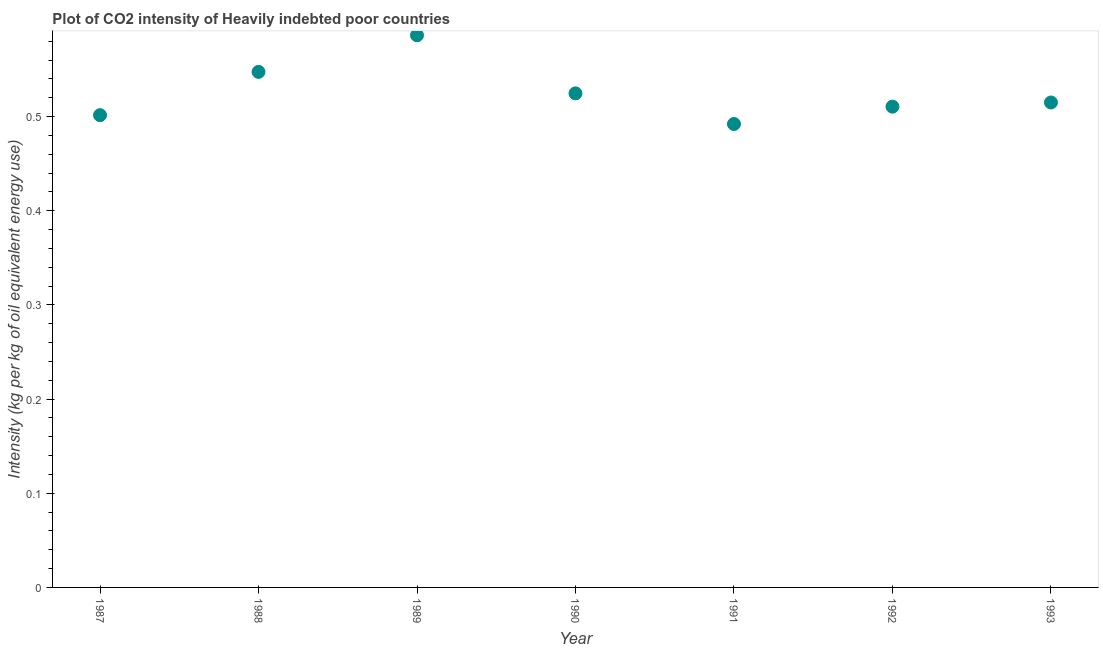What is the co2 intensity in 1993?
Offer a terse response. 0.51. Across all years, what is the maximum co2 intensity?
Your answer should be very brief. 0.59. Across all years, what is the minimum co2 intensity?
Offer a terse response. 0.49. In which year was the co2 intensity maximum?
Your answer should be compact. 1989. In which year was the co2 intensity minimum?
Keep it short and to the point. 1991. What is the sum of the co2 intensity?
Your response must be concise. 3.68. What is the difference between the co2 intensity in 1988 and 1993?
Keep it short and to the point. 0.03. What is the average co2 intensity per year?
Make the answer very short. 0.53. What is the median co2 intensity?
Your answer should be very brief. 0.51. Do a majority of the years between 1992 and 1991 (inclusive) have co2 intensity greater than 0.12000000000000001 kg?
Ensure brevity in your answer.  No. What is the ratio of the co2 intensity in 1990 to that in 1993?
Ensure brevity in your answer.  1.02. Is the difference between the co2 intensity in 1987 and 1992 greater than the difference between any two years?
Your response must be concise. No. What is the difference between the highest and the second highest co2 intensity?
Ensure brevity in your answer.  0.04. Is the sum of the co2 intensity in 1988 and 1990 greater than the maximum co2 intensity across all years?
Give a very brief answer. Yes. What is the difference between the highest and the lowest co2 intensity?
Your response must be concise. 0.09. Does the co2 intensity monotonically increase over the years?
Offer a very short reply. No. How many dotlines are there?
Ensure brevity in your answer.  1. How many years are there in the graph?
Your response must be concise. 7. What is the difference between two consecutive major ticks on the Y-axis?
Your answer should be very brief. 0.1. Are the values on the major ticks of Y-axis written in scientific E-notation?
Your response must be concise. No. Does the graph contain grids?
Your answer should be very brief. No. What is the title of the graph?
Make the answer very short. Plot of CO2 intensity of Heavily indebted poor countries. What is the label or title of the Y-axis?
Keep it short and to the point. Intensity (kg per kg of oil equivalent energy use). What is the Intensity (kg per kg of oil equivalent energy use) in 1987?
Make the answer very short. 0.5. What is the Intensity (kg per kg of oil equivalent energy use) in 1988?
Keep it short and to the point. 0.55. What is the Intensity (kg per kg of oil equivalent energy use) in 1989?
Keep it short and to the point. 0.59. What is the Intensity (kg per kg of oil equivalent energy use) in 1990?
Your answer should be compact. 0.52. What is the Intensity (kg per kg of oil equivalent energy use) in 1991?
Your answer should be very brief. 0.49. What is the Intensity (kg per kg of oil equivalent energy use) in 1992?
Your answer should be compact. 0.51. What is the Intensity (kg per kg of oil equivalent energy use) in 1993?
Make the answer very short. 0.51. What is the difference between the Intensity (kg per kg of oil equivalent energy use) in 1987 and 1988?
Your answer should be compact. -0.05. What is the difference between the Intensity (kg per kg of oil equivalent energy use) in 1987 and 1989?
Ensure brevity in your answer.  -0.08. What is the difference between the Intensity (kg per kg of oil equivalent energy use) in 1987 and 1990?
Your answer should be very brief. -0.02. What is the difference between the Intensity (kg per kg of oil equivalent energy use) in 1987 and 1991?
Provide a short and direct response. 0.01. What is the difference between the Intensity (kg per kg of oil equivalent energy use) in 1987 and 1992?
Ensure brevity in your answer.  -0.01. What is the difference between the Intensity (kg per kg of oil equivalent energy use) in 1987 and 1993?
Your answer should be compact. -0.01. What is the difference between the Intensity (kg per kg of oil equivalent energy use) in 1988 and 1989?
Provide a short and direct response. -0.04. What is the difference between the Intensity (kg per kg of oil equivalent energy use) in 1988 and 1990?
Make the answer very short. 0.02. What is the difference between the Intensity (kg per kg of oil equivalent energy use) in 1988 and 1991?
Offer a terse response. 0.06. What is the difference between the Intensity (kg per kg of oil equivalent energy use) in 1988 and 1992?
Make the answer very short. 0.04. What is the difference between the Intensity (kg per kg of oil equivalent energy use) in 1988 and 1993?
Your answer should be very brief. 0.03. What is the difference between the Intensity (kg per kg of oil equivalent energy use) in 1989 and 1990?
Your response must be concise. 0.06. What is the difference between the Intensity (kg per kg of oil equivalent energy use) in 1989 and 1991?
Offer a terse response. 0.09. What is the difference between the Intensity (kg per kg of oil equivalent energy use) in 1989 and 1992?
Offer a terse response. 0.08. What is the difference between the Intensity (kg per kg of oil equivalent energy use) in 1989 and 1993?
Your response must be concise. 0.07. What is the difference between the Intensity (kg per kg of oil equivalent energy use) in 1990 and 1991?
Your answer should be very brief. 0.03. What is the difference between the Intensity (kg per kg of oil equivalent energy use) in 1990 and 1992?
Provide a short and direct response. 0.01. What is the difference between the Intensity (kg per kg of oil equivalent energy use) in 1990 and 1993?
Keep it short and to the point. 0.01. What is the difference between the Intensity (kg per kg of oil equivalent energy use) in 1991 and 1992?
Your answer should be compact. -0.02. What is the difference between the Intensity (kg per kg of oil equivalent energy use) in 1991 and 1993?
Your answer should be compact. -0.02. What is the difference between the Intensity (kg per kg of oil equivalent energy use) in 1992 and 1993?
Ensure brevity in your answer.  -0. What is the ratio of the Intensity (kg per kg of oil equivalent energy use) in 1987 to that in 1988?
Give a very brief answer. 0.92. What is the ratio of the Intensity (kg per kg of oil equivalent energy use) in 1987 to that in 1989?
Give a very brief answer. 0.85. What is the ratio of the Intensity (kg per kg of oil equivalent energy use) in 1987 to that in 1990?
Your answer should be very brief. 0.96. What is the ratio of the Intensity (kg per kg of oil equivalent energy use) in 1987 to that in 1991?
Offer a terse response. 1.02. What is the ratio of the Intensity (kg per kg of oil equivalent energy use) in 1987 to that in 1992?
Keep it short and to the point. 0.98. What is the ratio of the Intensity (kg per kg of oil equivalent energy use) in 1988 to that in 1989?
Provide a succinct answer. 0.93. What is the ratio of the Intensity (kg per kg of oil equivalent energy use) in 1988 to that in 1990?
Keep it short and to the point. 1.04. What is the ratio of the Intensity (kg per kg of oil equivalent energy use) in 1988 to that in 1991?
Your answer should be compact. 1.11. What is the ratio of the Intensity (kg per kg of oil equivalent energy use) in 1988 to that in 1992?
Ensure brevity in your answer.  1.07. What is the ratio of the Intensity (kg per kg of oil equivalent energy use) in 1988 to that in 1993?
Provide a succinct answer. 1.06. What is the ratio of the Intensity (kg per kg of oil equivalent energy use) in 1989 to that in 1990?
Provide a succinct answer. 1.12. What is the ratio of the Intensity (kg per kg of oil equivalent energy use) in 1989 to that in 1991?
Give a very brief answer. 1.19. What is the ratio of the Intensity (kg per kg of oil equivalent energy use) in 1989 to that in 1992?
Your response must be concise. 1.15. What is the ratio of the Intensity (kg per kg of oil equivalent energy use) in 1989 to that in 1993?
Your answer should be very brief. 1.14. What is the ratio of the Intensity (kg per kg of oil equivalent energy use) in 1990 to that in 1991?
Give a very brief answer. 1.07. What is the ratio of the Intensity (kg per kg of oil equivalent energy use) in 1990 to that in 1992?
Make the answer very short. 1.03. What is the ratio of the Intensity (kg per kg of oil equivalent energy use) in 1991 to that in 1992?
Provide a succinct answer. 0.96. What is the ratio of the Intensity (kg per kg of oil equivalent energy use) in 1991 to that in 1993?
Keep it short and to the point. 0.96. What is the ratio of the Intensity (kg per kg of oil equivalent energy use) in 1992 to that in 1993?
Provide a succinct answer. 0.99. 